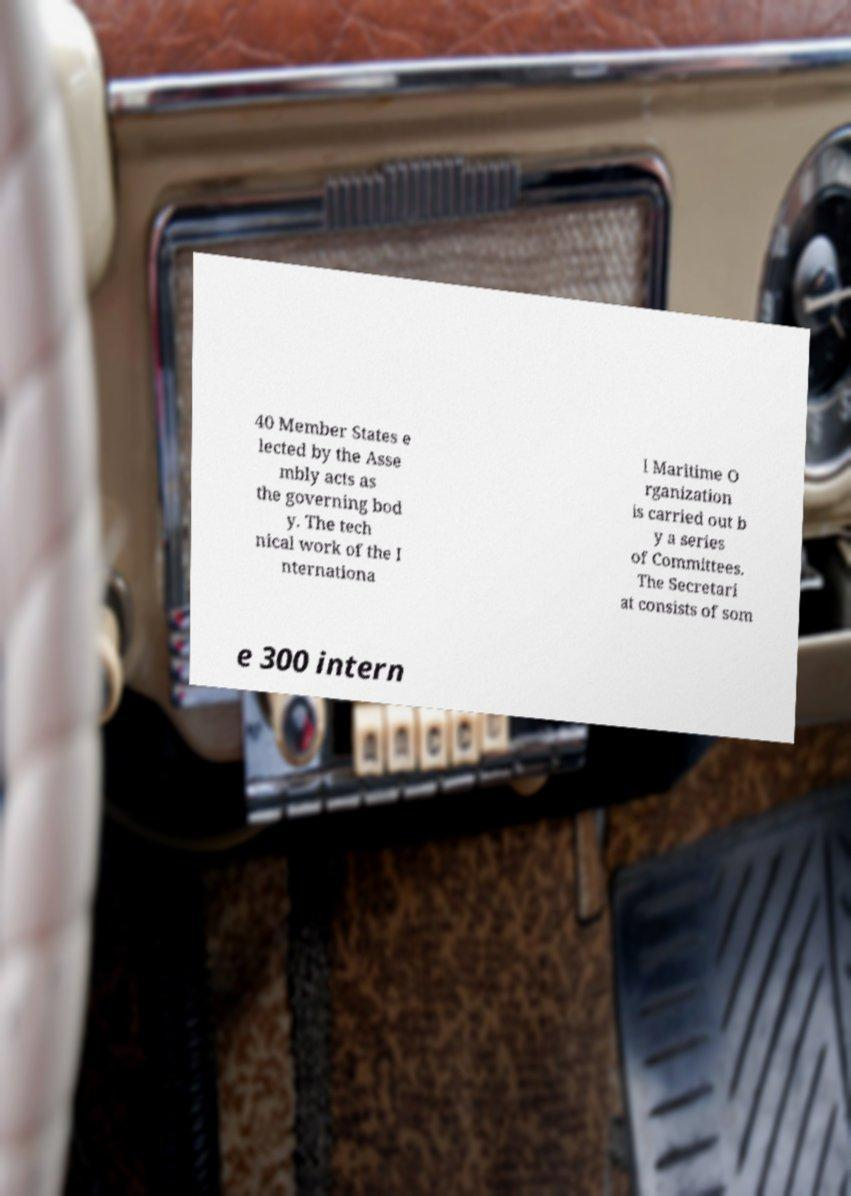Could you assist in decoding the text presented in this image and type it out clearly? 40 Member States e lected by the Asse mbly acts as the governing bod y. The tech nical work of the I nternationa l Maritime O rganization is carried out b y a series of Committees. The Secretari at consists of som e 300 intern 